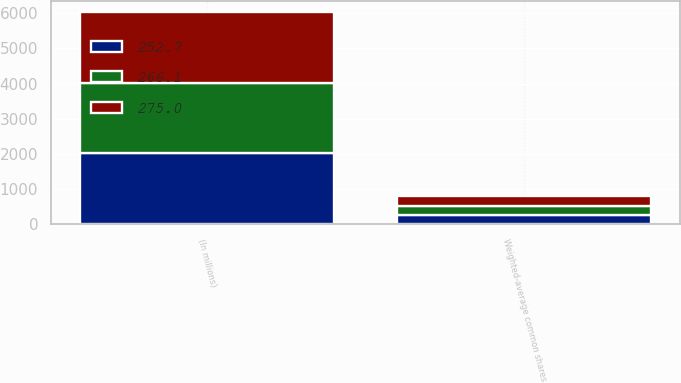Convert chart to OTSL. <chart><loc_0><loc_0><loc_500><loc_500><stacked_bar_chart><ecel><fcel>(In millions)<fcel>Weighted-average common shares<nl><fcel>252.7<fcel>2014<fcel>252.7<nl><fcel>266.1<fcel>2013<fcel>266.1<nl><fcel>275<fcel>2012<fcel>275<nl></chart> 